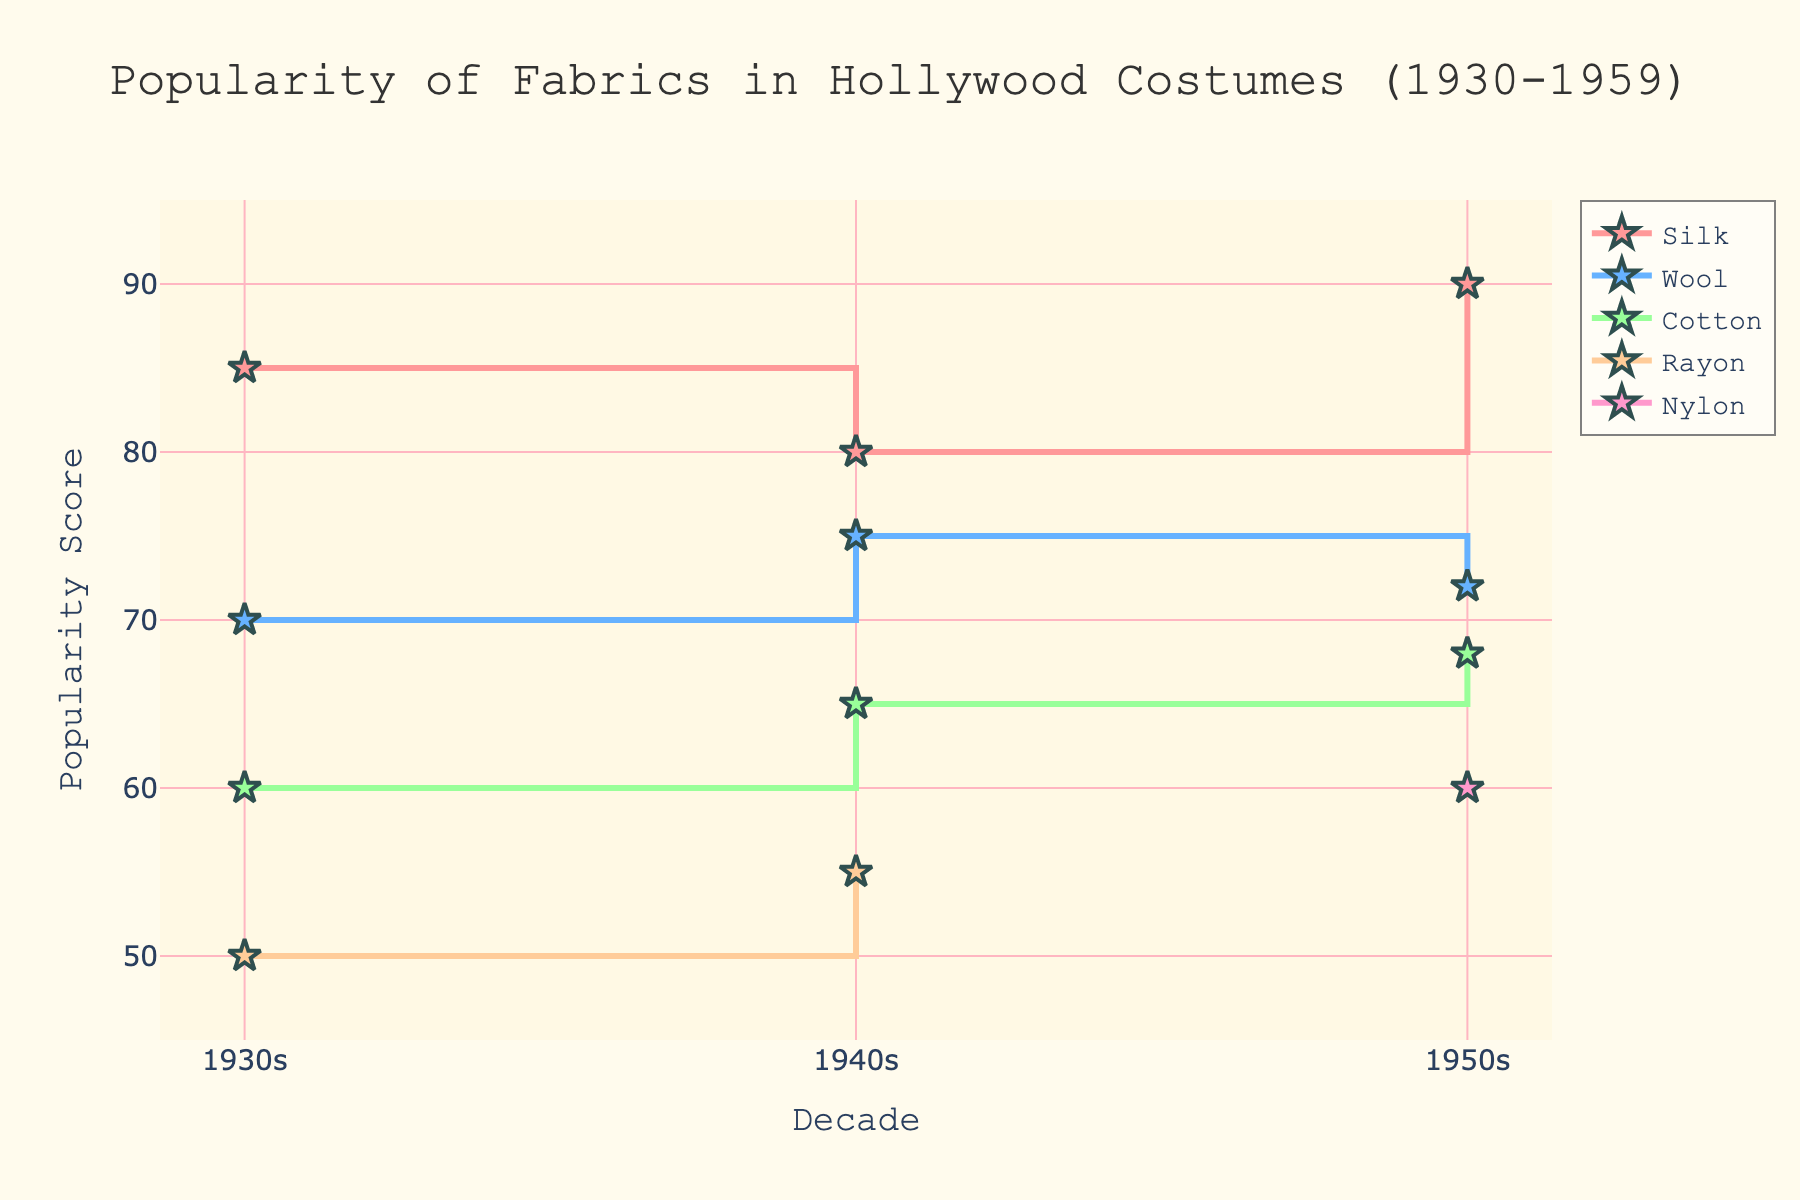What's the title of the plot? The title is displayed at the top center of the plot and reads "Popularity of Fabrics in Hollywood Costumes (1930-1959)."
Answer: Popularity of Fabrics in Hollywood Costumes (1930-1959) What is the highest popularity score assigned to Silk in any decade? By observing the Silk's data points on the graph, the highest score assigned to Silk is in the 1950s at 90.
Answer: 90 Which fabric shows a new appearance in the 1950s that was not present in the 1930s and 1940s? By comparing the fabric legends and data points across the decades, Nylon appears only in the 1950s, not in the 1930s or 1940s.
Answer: Nylon How did the popularity score of Wool change from the 1930s to the 1940s? Wool's score increased from 70 in the 1930s to 75 in the 1940s which is an increase of 5 points.
Answer: Increased by 5 points What fabric had the lowest popularity score in the 1930s? By observing the plot, Rayon has the lowest popularity score in the 1930s with a score of 50.
Answer: Rayon Which fabric shows the highest increase in popularity score from the 1940s to the 1950s? By examining the changes in scores from the 1940s to the 1950s, Silk has the highest increase going from 80 to 90, an increase of 10 points.
Answer: Silk What is the average popularity score of Cotton across the three decades? The scores for Cotton are 60, 65, and 68 for the 1930s, 1940s, and 1950s. The average is calculated as (60 + 65 + 68)/3 = 193/3 = 64.33.
Answer: 64.33 Between Wool and Rayon, which fabric has a more stable popularity score trend throughout the decades? Wool has scores of 70, 75, and 72 showing minor fluctuations, whereas Rayon shows a stable yet low trend from 50 to 55. Wool's scores fluctuate but less drastically than Rayon's relative change.
Answer: Wool Which decade shows the most diversity in fabric types used in Hollywood costumes? The 1950s show the most diversity with the appearance of four different fabrics: Silk, Wool, Cotton, and Nylon, unlike the 1930s and 1940s which only have three fabrics.
Answer: 1950s 